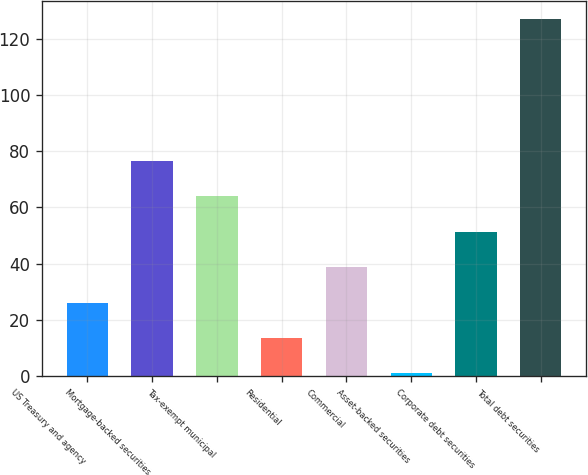Convert chart to OTSL. <chart><loc_0><loc_0><loc_500><loc_500><bar_chart><fcel>US Treasury and agency<fcel>Mortgage-backed securities<fcel>Tax-exempt municipal<fcel>Residential<fcel>Commercial<fcel>Asset-backed securities<fcel>Corporate debt securities<fcel>Total debt securities<nl><fcel>26.2<fcel>76.6<fcel>64<fcel>13.6<fcel>38.8<fcel>1<fcel>51.4<fcel>127<nl></chart> 